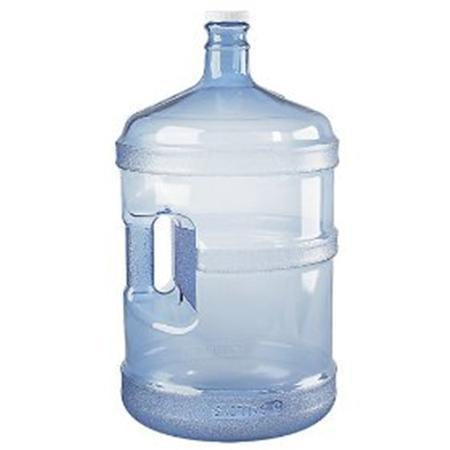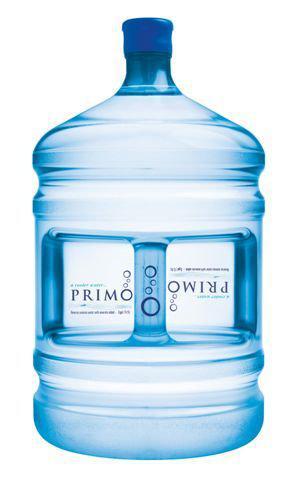The first image is the image on the left, the second image is the image on the right. Examine the images to the left and right. Is the description "An image contains a rack holding large water bottles." accurate? Answer yes or no. No. The first image is the image on the left, the second image is the image on the right. Considering the images on both sides, is "Every image has a fully stocked tower of blue water jugs with at least three levels." valid? Answer yes or no. No. 